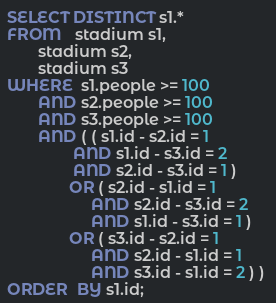Convert code to text. <code><loc_0><loc_0><loc_500><loc_500><_SQL_>SELECT DISTINCT s1.* 
FROM   stadium s1, 
       stadium s2, 
       stadium s3 
WHERE  s1.people >= 100 
       AND s2.people >= 100 
       AND s3.people >= 100 
       AND ( ( s1.id - s2.id = 1 
               AND s1.id - s3.id = 2 
               AND s2.id - s3.id = 1 ) 
              OR ( s2.id - s1.id = 1 
                   AND s2.id - s3.id = 2 
                   AND s1.id - s3.id = 1 ) 
              OR ( s3.id - s2.id = 1 
                   AND s2.id - s1.id = 1 
                   AND s3.id - s1.id = 2 ) ) 
ORDER  BY s1.id;</code> 